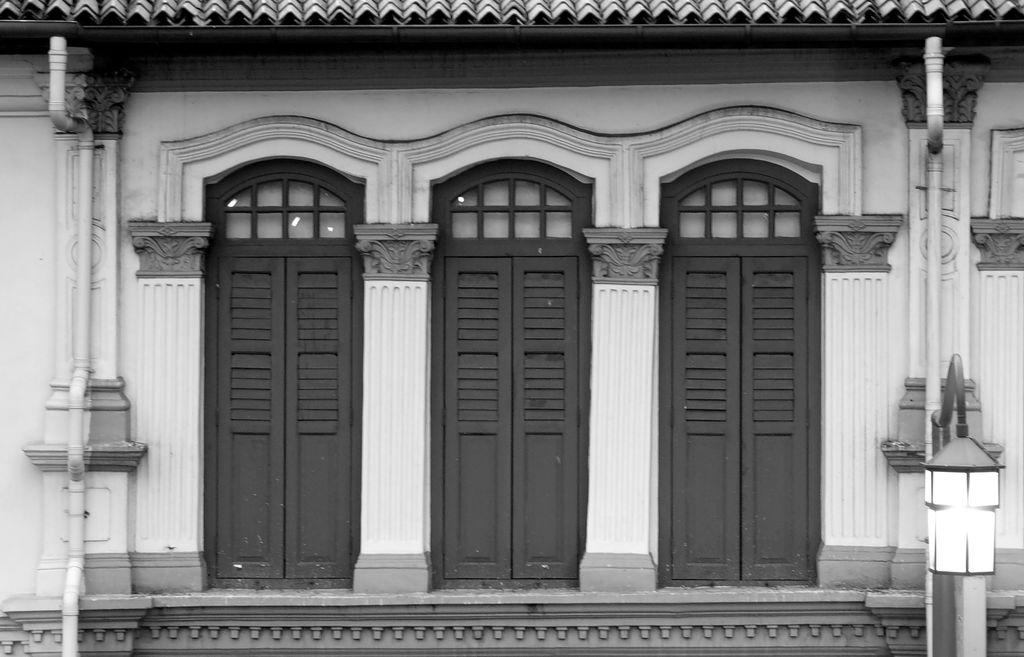What type of structure is visible in the image? There is a building in the image. What specific features can be seen on the building? The building has pipelines, pillars, windows, electric lights, and walls. What route does the team of laborers take to reach the building in the image? There is no team or laborers present in the image, so it is not possible to determine a route. 